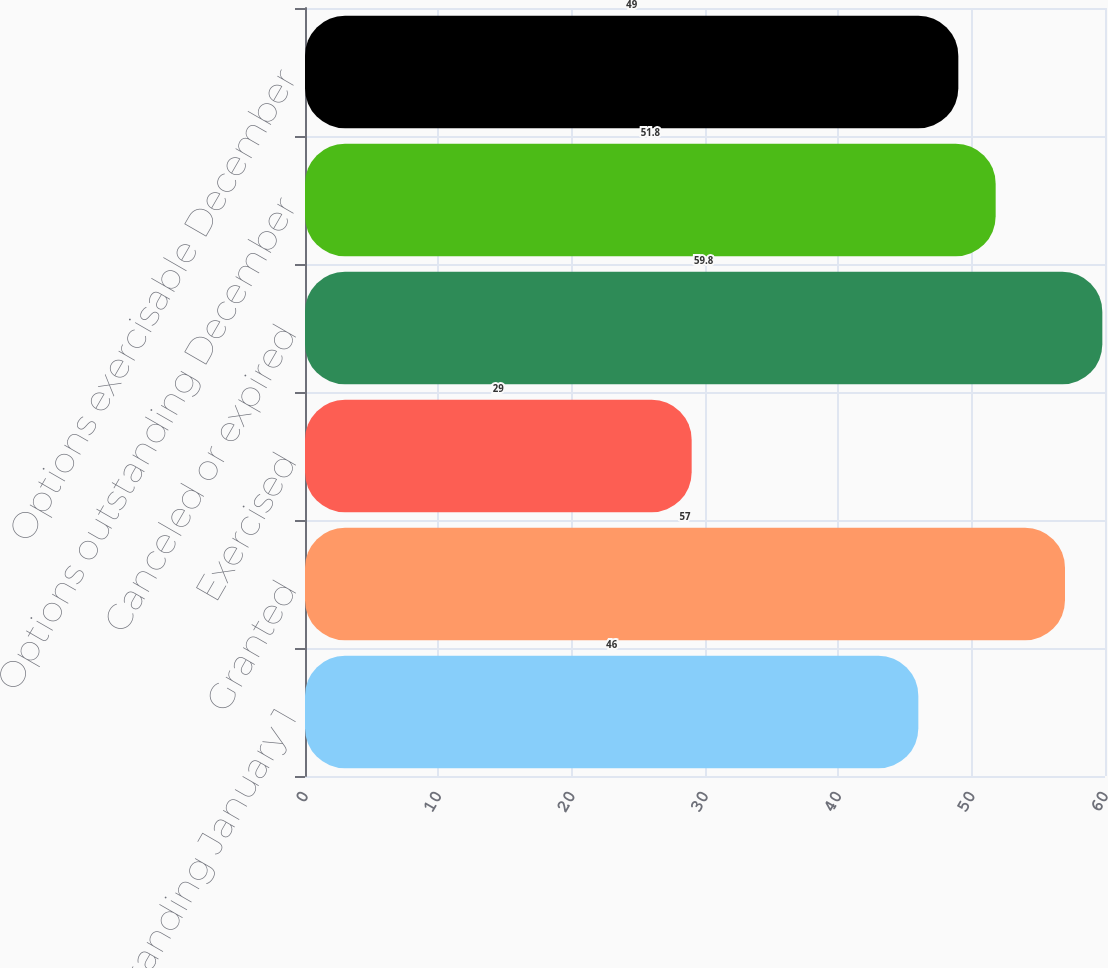<chart> <loc_0><loc_0><loc_500><loc_500><bar_chart><fcel>Options outstanding January 1<fcel>Granted<fcel>Exercised<fcel>Canceled or expired<fcel>Options outstanding December<fcel>Options exercisable December<nl><fcel>46<fcel>57<fcel>29<fcel>59.8<fcel>51.8<fcel>49<nl></chart> 